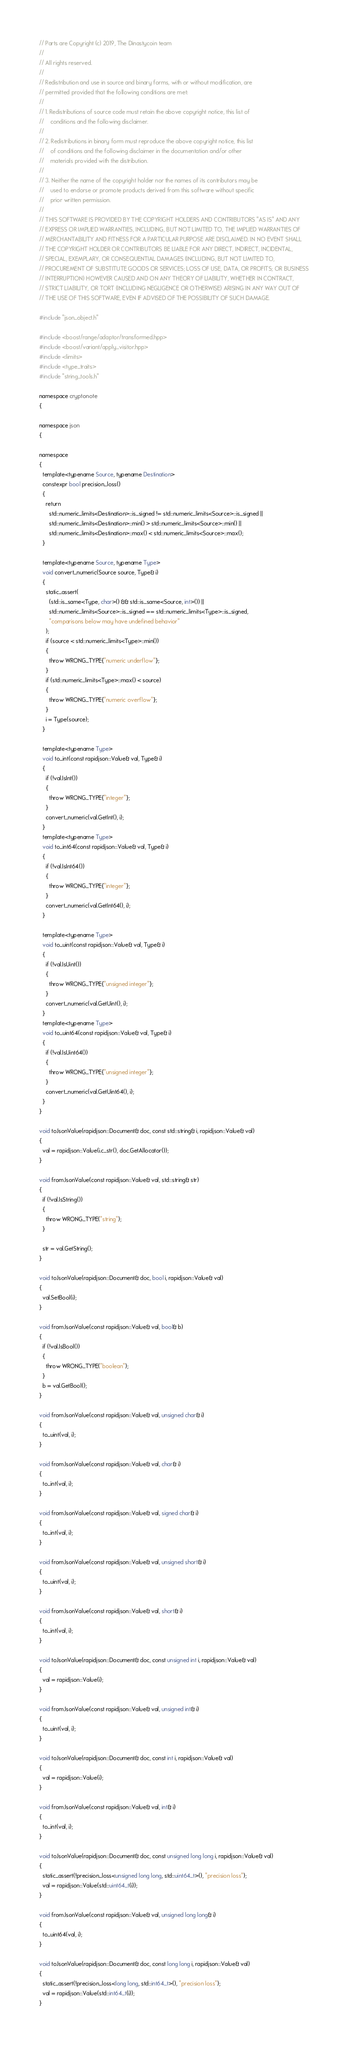Convert code to text. <code><loc_0><loc_0><loc_500><loc_500><_C++_>// Parts are Copyright (c) 2019, The Dinastycoin team
// 
// All rights reserved.
// 
// Redistribution and use in source and binary forms, with or without modification, are
// permitted provided that the following conditions are met:
// 
// 1. Redistributions of source code must retain the above copyright notice, this list of
//    conditions and the following disclaimer.
// 
// 2. Redistributions in binary form must reproduce the above copyright notice, this list
//    of conditions and the following disclaimer in the documentation and/or other
//    materials provided with the distribution.
// 
// 3. Neither the name of the copyright holder nor the names of its contributors may be
//    used to endorse or promote products derived from this software without specific
//    prior written permission.
// 
// THIS SOFTWARE IS PROVIDED BY THE COPYRIGHT HOLDERS AND CONTRIBUTORS "AS IS" AND ANY
// EXPRESS OR IMPLIED WARRANTIES, INCLUDING, BUT NOT LIMITED TO, THE IMPLIED WARRANTIES OF
// MERCHANTABILITY AND FITNESS FOR A PARTICULAR PURPOSE ARE DISCLAIMED. IN NO EVENT SHALL
// THE COPYRIGHT HOLDER OR CONTRIBUTORS BE LIABLE FOR ANY DIRECT, INDIRECT, INCIDENTAL,
// SPECIAL, EXEMPLARY, OR CONSEQUENTIAL DAMAGES (INCLUDING, BUT NOT LIMITED TO,
// PROCUREMENT OF SUBSTITUTE GOODS OR SERVICES; LOSS OF USE, DATA, OR PROFITS; OR BUSINESS
// INTERRUPTION) HOWEVER CAUSED AND ON ANY THEORY OF LIABILITY, WHETHER IN CONTRACT,
// STRICT LIABILITY, OR TORT (INCLUDING NEGLIGENCE OR OTHERWISE) ARISING IN ANY WAY OUT OF
// THE USE OF THIS SOFTWARE, EVEN IF ADVISED OF THE POSSIBILITY OF SUCH DAMAGE.

#include "json_object.h"

#include <boost/range/adaptor/transformed.hpp>
#include <boost/variant/apply_visitor.hpp>
#include <limits>
#include <type_traits>
#include "string_tools.h"

namespace cryptonote
{

namespace json
{

namespace
{
  template<typename Source, typename Destination>
  constexpr bool precision_loss()
  {
    return
      std::numeric_limits<Destination>::is_signed != std::numeric_limits<Source>::is_signed ||
      std::numeric_limits<Destination>::min() > std::numeric_limits<Source>::min() ||
      std::numeric_limits<Destination>::max() < std::numeric_limits<Source>::max();
  }

  template<typename Source, typename Type>
  void convert_numeric(Source source, Type& i)
  {
    static_assert(
      (std::is_same<Type, char>() && std::is_same<Source, int>()) ||
      std::numeric_limits<Source>::is_signed == std::numeric_limits<Type>::is_signed,
      "comparisons below may have undefined behavior"
    );
    if (source < std::numeric_limits<Type>::min())
    {
      throw WRONG_TYPE{"numeric underflow"};
    }
    if (std::numeric_limits<Type>::max() < source)
    {
      throw WRONG_TYPE{"numeric overflow"};
    }
    i = Type(source);
  }

  template<typename Type>
  void to_int(const rapidjson::Value& val, Type& i)
  {
    if (!val.IsInt())
    {
      throw WRONG_TYPE{"integer"};
    }
    convert_numeric(val.GetInt(), i);
  }
  template<typename Type>
  void to_int64(const rapidjson::Value& val, Type& i)
  {
    if (!val.IsInt64())
    {
      throw WRONG_TYPE{"integer"};
    }
    convert_numeric(val.GetInt64(), i);
  }

  template<typename Type>
  void to_uint(const rapidjson::Value& val, Type& i)
  {
    if (!val.IsUint())
    {
      throw WRONG_TYPE{"unsigned integer"};
    }
    convert_numeric(val.GetUint(), i);
  }
  template<typename Type>
  void to_uint64(const rapidjson::Value& val, Type& i)
  {
    if (!val.IsUint64())
    {
      throw WRONG_TYPE{"unsigned integer"};
    }
    convert_numeric(val.GetUint64(), i);
  }
}

void toJsonValue(rapidjson::Document& doc, const std::string& i, rapidjson::Value& val)
{
  val = rapidjson::Value(i.c_str(), doc.GetAllocator());
}

void fromJsonValue(const rapidjson::Value& val, std::string& str)
{
  if (!val.IsString())
  {
    throw WRONG_TYPE("string");
  }

  str = val.GetString();
}

void toJsonValue(rapidjson::Document& doc, bool i, rapidjson::Value& val)
{
  val.SetBool(i);
}

void fromJsonValue(const rapidjson::Value& val, bool& b)
{
  if (!val.IsBool())
  {
    throw WRONG_TYPE("boolean");
  }
  b = val.GetBool();
}

void fromJsonValue(const rapidjson::Value& val, unsigned char& i)
{
  to_uint(val, i);
}

void fromJsonValue(const rapidjson::Value& val, char& i)
{
  to_int(val, i);
}

void fromJsonValue(const rapidjson::Value& val, signed char& i)
{
  to_int(val, i);
}

void fromJsonValue(const rapidjson::Value& val, unsigned short& i)
{
  to_uint(val, i);
}

void fromJsonValue(const rapidjson::Value& val, short& i)
{
  to_int(val, i);
}

void toJsonValue(rapidjson::Document& doc, const unsigned int i, rapidjson::Value& val)
{
  val = rapidjson::Value(i);
}

void fromJsonValue(const rapidjson::Value& val, unsigned int& i)
{
  to_uint(val, i);
}

void toJsonValue(rapidjson::Document& doc, const int i, rapidjson::Value& val)
{
  val = rapidjson::Value(i);
}

void fromJsonValue(const rapidjson::Value& val, int& i)
{
  to_int(val, i);
}

void toJsonValue(rapidjson::Document& doc, const unsigned long long i, rapidjson::Value& val)
{
  static_assert(!precision_loss<unsigned long long, std::uint64_t>(), "precision loss");
  val = rapidjson::Value(std::uint64_t(i));
}

void fromJsonValue(const rapidjson::Value& val, unsigned long long& i)
{
  to_uint64(val, i);
}

void toJsonValue(rapidjson::Document& doc, const long long i, rapidjson::Value& val)
{
  static_assert(!precision_loss<long long, std::int64_t>(), "precision loss");
  val = rapidjson::Value(std::int64_t(i));
}
</code> 